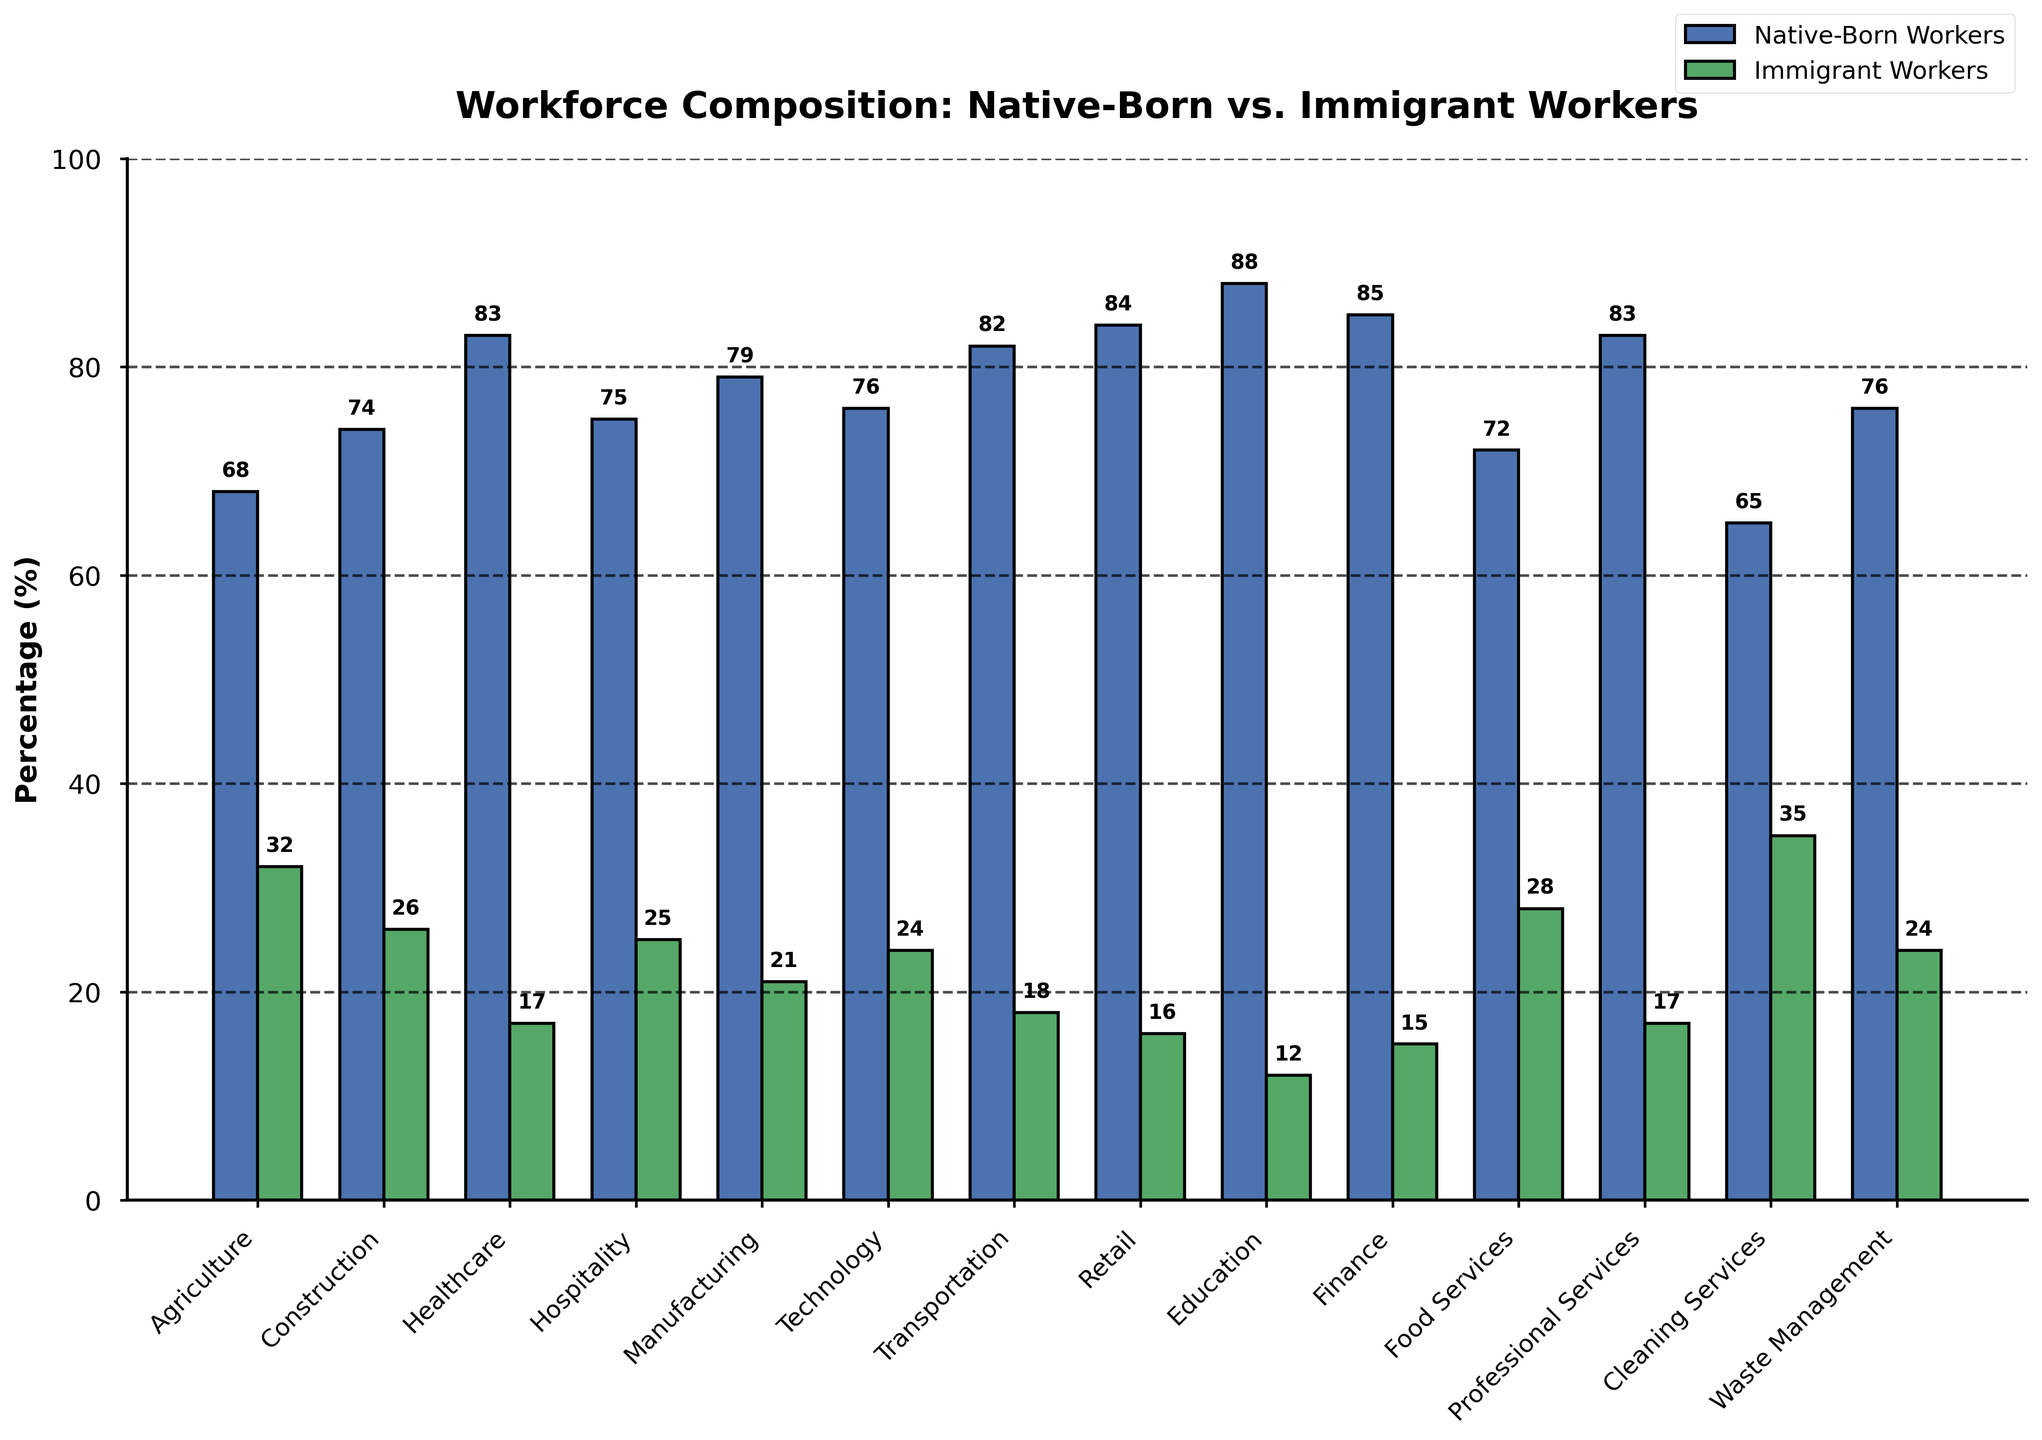What industry has the highest percentage of native-born workers? The bar for Education has the highest value for native-born workers, with a label indicating 88%.
Answer: Education Which industry has the highest proportion of immigrant workers? The bar for Cleaning Services shows the highest value for immigrant workers, with a label indicating 35%.
Answer: Cleaning Services Compare the percentage of native-born workers in Agriculture and Technology. Which is higher and by how much? Agriculture has 68% native-born workers, while Technology has 76%. The difference is 76 - 68 = 8%.
Answer: Technology by 8% In which industries do immigrant workers make up more than 30% of the workforce? The bars for Agriculture (32%) and Cleaning Services (35%) indicate that immigrant workers make up more than 30% of the workforce.
Answer: Agriculture, Cleaning Services Calculate the average percentage of immigrant workers in Healthcare, Education, and Finance. The percentages are Healthcare (17%), Education (12%), and Finance (15%). The average is (17 + 12 + 15) / 3 = 14.67%.
Answer: 14.67% Which industry has the smallest difference in the percentage between native-born and immigrant workers? Cleaning Services has native-born workers at 65% and immigrant workers at 35%, making the difference 65 - 35 = 30%. This difference is the smallest.
Answer: Cleaning Services Examine the proportion of immigrant workers in Construction and Transportation. How do they compare? Construction has 26% immigrant workers, and Transportation has 18%. The difference is 26 - 18 = 8%.
Answer: Construction has 8% more What is the combined percentage of native-born workers in the Healthcare and Professional Services industries? Healthcare has 83% native-born workers, and Professional Services also has 83%. The combined percentage is 83 + 83 = 166%.
Answer: 166% Which industry has a higher percentage of immigrant workers: Food Services or Manufacturing? The percentage of immigrant workers in Food Services is 28%, and in Manufacturing, it's 21%.
Answer: Food Services Compare the sums of the percentages of native-born and immigrant workers in Hospitality and Retail. Are they equal? Hospitality has native-born (75%) and immigrant (25%) workers summing to 100%. Retail has native-born (84%) and immigrant (16%) workers summing to 100%. Therefore, they are equal.
Answer: Yes 